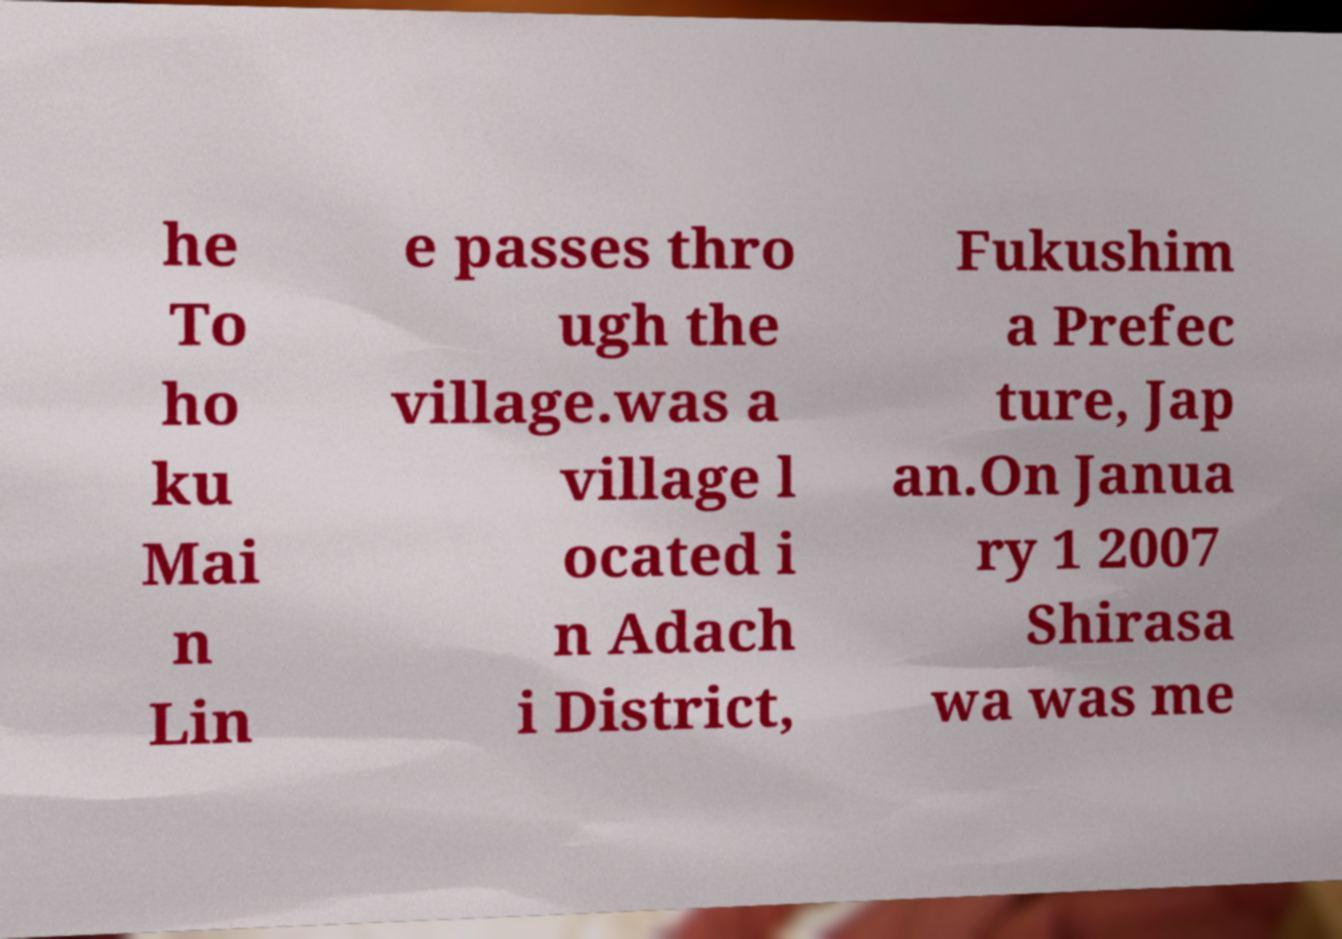Please identify and transcribe the text found in this image. he To ho ku Mai n Lin e passes thro ugh the village.was a village l ocated i n Adach i District, Fukushim a Prefec ture, Jap an.On Janua ry 1 2007 Shirasa wa was me 